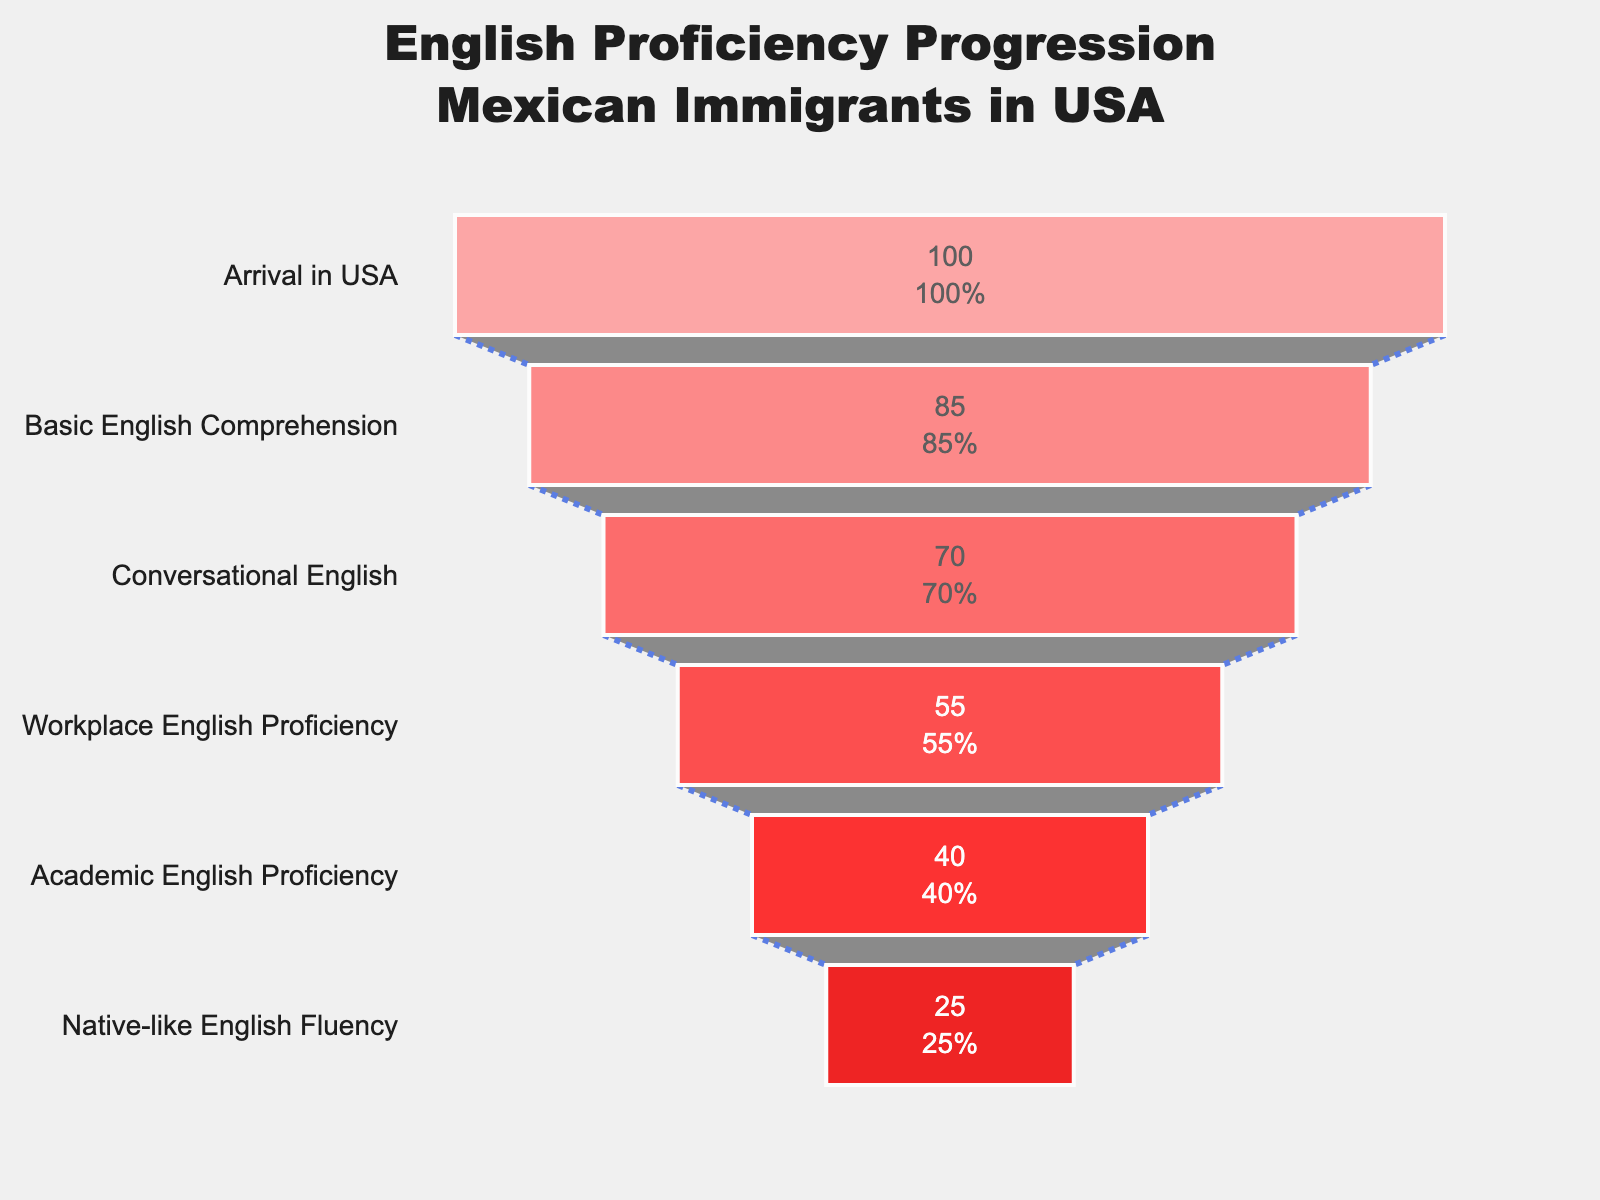How many stages are represented in the funnel chart? To determine the number of stages represented in the funnel chart, count the distinct stage names listed on the y-axis. The stages included are "Arrival in USA", "Basic English Comprehension", "Conversational English", "Workplace English Proficiency", "Academic English Proficiency", and "Native-like English Fluency". That's a total of 6 stages.
Answer: 6 What is the title of the figure? The title is typically found at the top of the figure in a larger, bold font. In this case, it reads "English Proficiency Progression Mexican Immigrants in USA".
Answer: English Proficiency Progression Mexican Immigrants in USA What percentage of first-generation Mexican immigrants reach Academic English Proficiency? The percentage is displayed within the funnel section corresponding to "Academic English Proficiency." Looking at the figure, this percentage is shown as 40%.
Answer: 40% How many percentage points decrease from Basic English Comprehension to Conversational English? To find the decrease, subtract the percentage of Conversational English (70%) from the percentage of Basic English Comprehension (85%). This calculation gives us 85% - 70% = 15%.
Answer: 15% Which stage has a percentage value of 55%? Look for the stage name corresponding to the percentage value of 55% within the funnel chart. According to the figure, 55% corresponds to "Workplace English Proficiency".
Answer: Workplace English Proficiency What is the difference in percentage between Conversational English and Native-like English Fluency? Subtract the percentage for Native-like English Fluency (25%) from the percentage for Conversational English (70%). The difference is calculated as 70% - 25% = 45%.
Answer: 45% Which stage shows the highest percentage drop in English proficiency? Compare the percentage drops between consecutive stages. The drop from Basic English Comprehension (85%) to Conversational English (70%) is 15 percentage points. The drop from Conversational English (70%) to Workplace English Proficiency (55%) is also 15 percentage points. The drop from Workplace English Proficiency (55%) to Academic English Proficiency (40%) is another 15 percentage points. Finally, from Academic English Proficiency (40%) to Native-like English Fluency (25%) is again 15 percentage points. Since all drops are the same, no single stage shows the highest percentage drop.
Answer: All drops are equal What is the average percentage from the given stages? To calculate the average percentage, sum all the percentage values and then divide by the number of stages. The sum of percentages (100 + 85 + 70 + 55 + 40 + 25) is 375, and there are 6 stages, so the average is 375 / 6 = 62.5%.
Answer: 62.5% What is the progression percentage from Arrival in the USA to Basic English Comprehension? The progression percentage from one stage to the next can be found by observing the drop between these two specific segments. As mentioned before, Basic English Comprehension is at 85%, and Arrival in the USA is considered to be at 100%. The drop from 100% to 85% represents a progression of 85% in Basic English Comprehension.
Answer: 85% How does the percentage for Native-like English Fluency compare to Workplace English Proficiency? Compare the given percentages directly. Native-like English Fluency is at 25%, while Workplace English Proficiency is at 55%. Subtracting 25% from 55% results in a difference of 30 percentage points, indicating that significantly fewer people achieve Native-like English Fluency compared to Workplace English Proficiency.
Answer: Workplace English Proficiency is 30 percentage points higher than Native-like English Fluency 